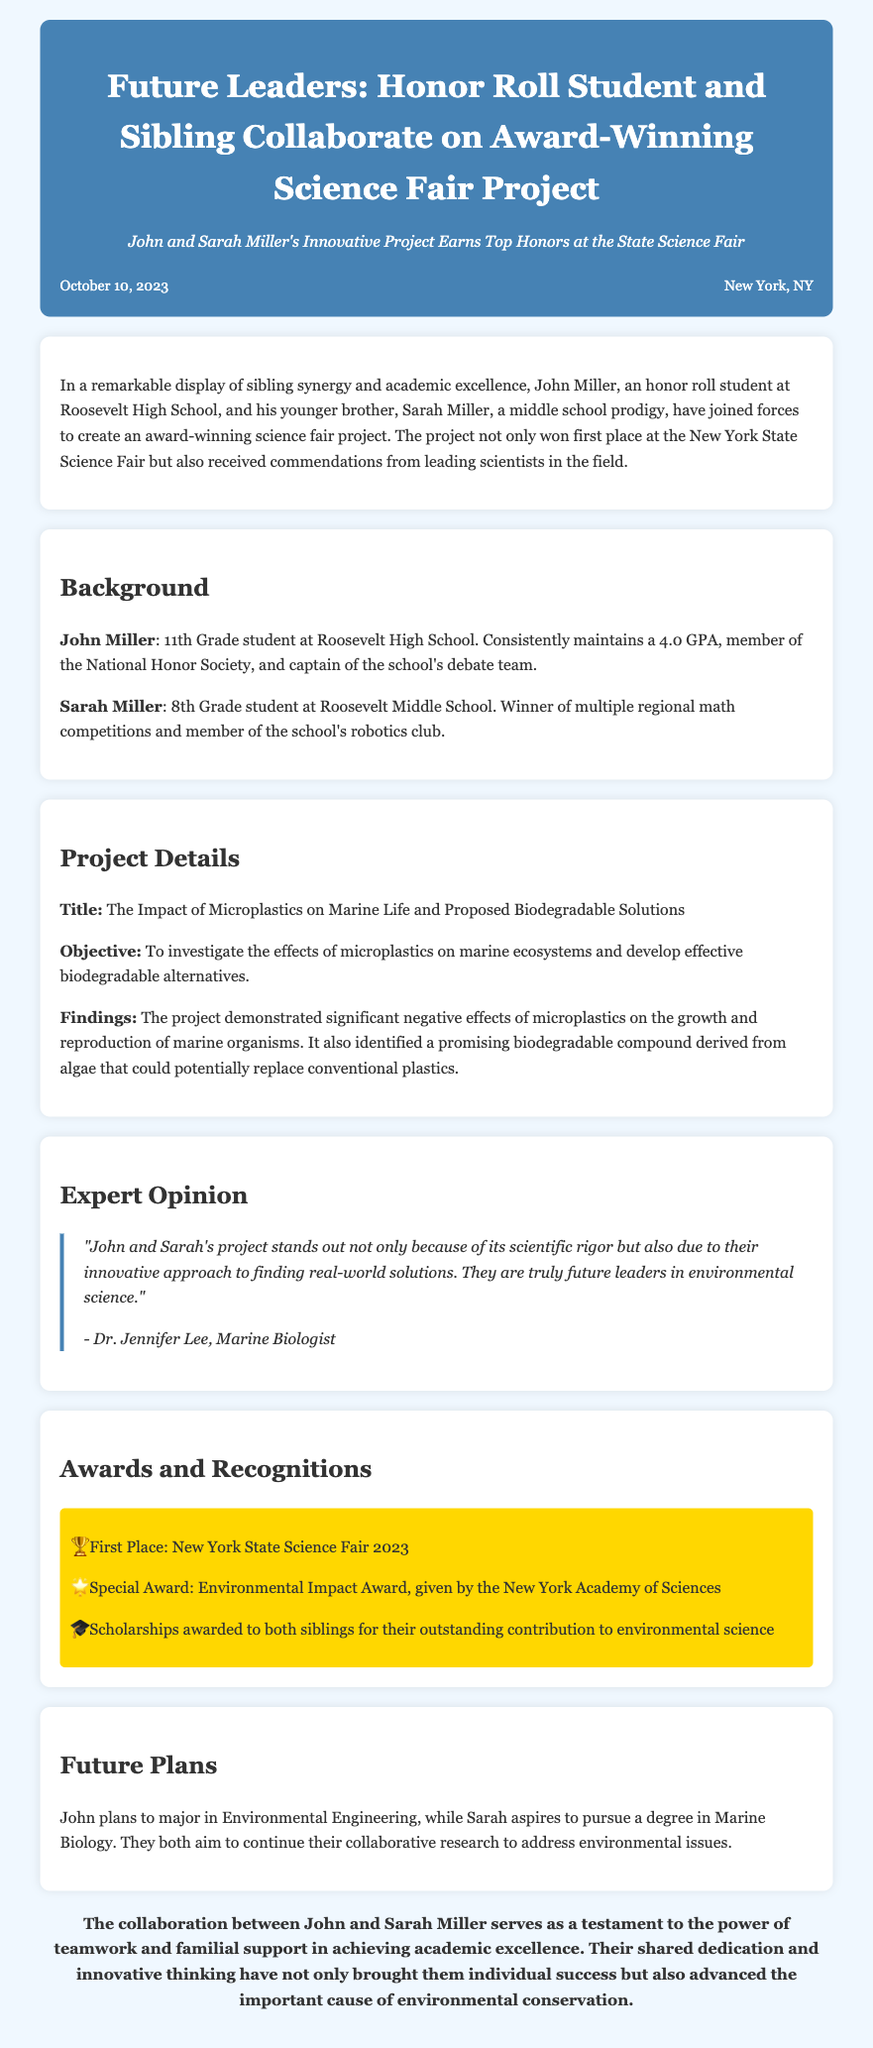What is the title of the project? The title is found in the Project Details section.
Answer: The Impact of Microplastics on Marine Life and Proposed Biodegradable Solutions Who are the students involved in the project? The document lists the names of the students in the introduction.
Answer: John and Sarah Miller When was the press release published? The publication date is mentioned in the metadata of the document.
Answer: October 10, 2023 What grade is John Miller in? The background section states John's educational level.
Answer: 11th Grade What award did the project receive from the New York Academy of Sciences? The awards section lists the special recognition received.
Answer: Environmental Impact Award What is Sarah Miller's aspiration? The document mentions her future plans in the Future Plans section.
Answer: Marine Biology How did the experts describe John and Sarah's project? The expert opinion section contains a direct quote about the project.
Answer: Future leaders in environmental science What is John Miller's GPA? The background section includes John's academic performance.
Answer: 4.0 GPA 